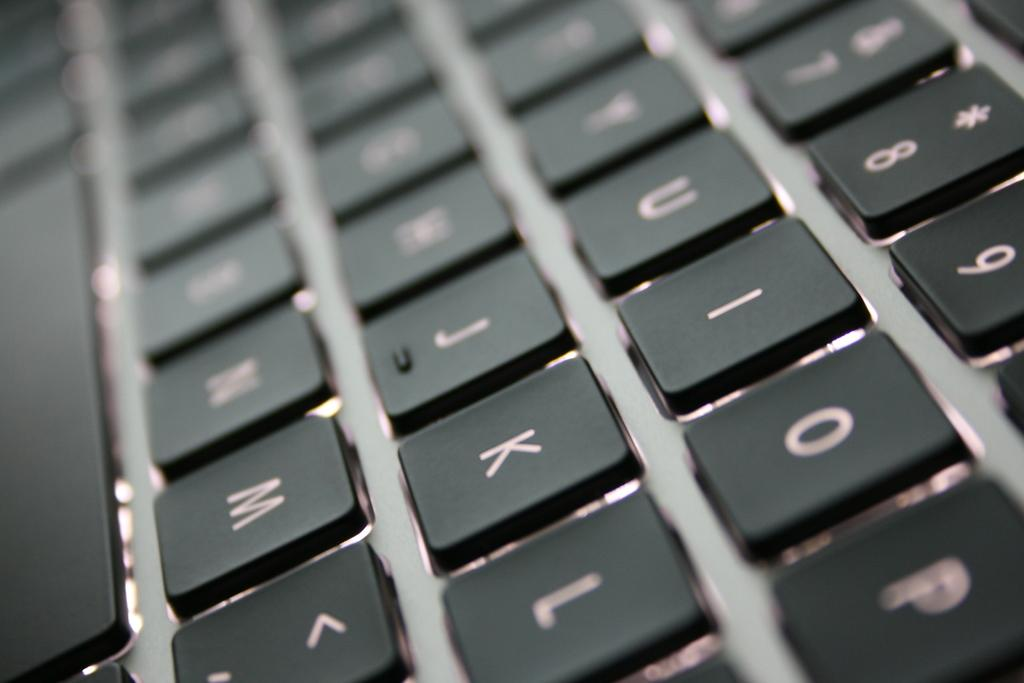What is the main object in the image? There is a keyboard in the image. What is the color of the buttons on the keyboard? The buttons on the keyboard are black in color. What can be found on each button of the keyboard? Each button on the keyboard has letters and numbers on it. How does the governor interact with the keyboard in the image? There is no governor present in the image, so it is not possible to answer that question. 